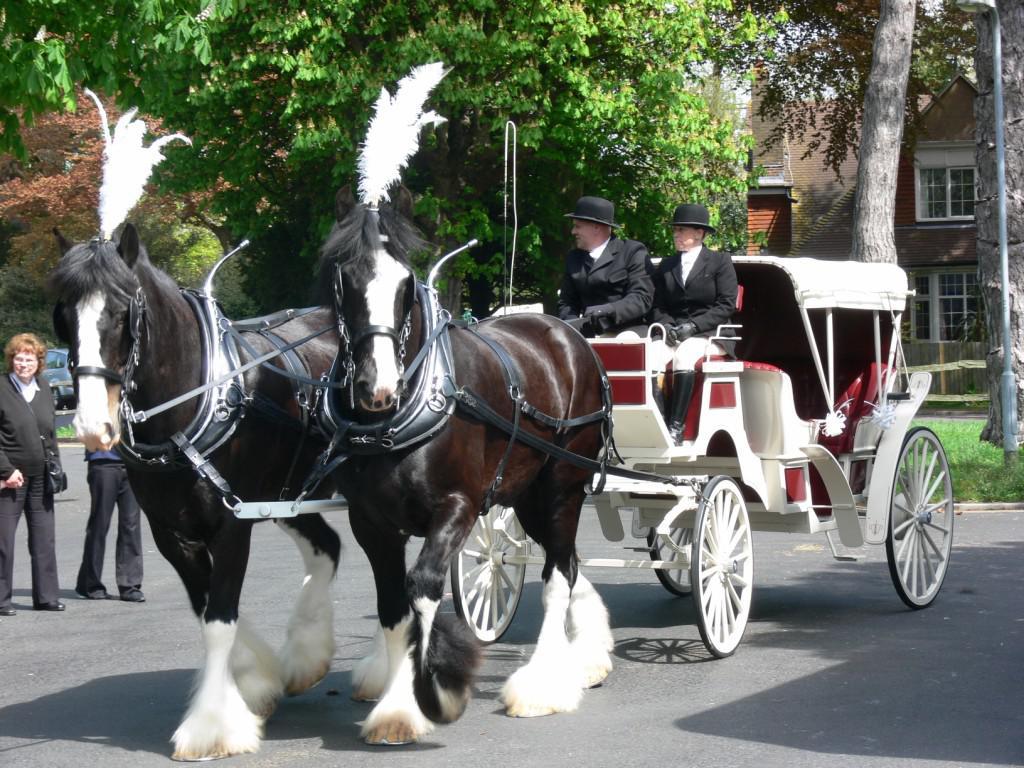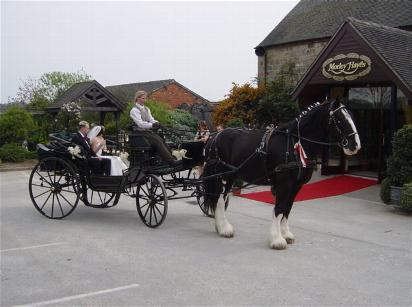The first image is the image on the left, the second image is the image on the right. Evaluate the accuracy of this statement regarding the images: "None of the wagons has more than a single person in the front seat.". Is it true? Answer yes or no. No. The first image is the image on the left, the second image is the image on the right. Analyze the images presented: Is the assertion "The horse carriage are facing opposite directions from each other." valid? Answer yes or no. Yes. 